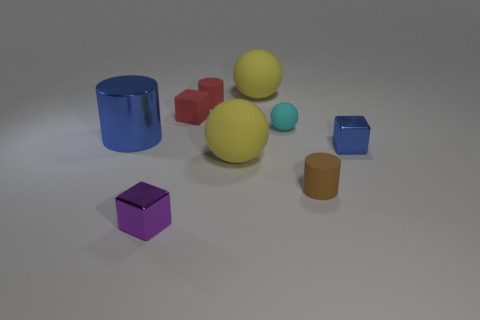What is the largest object in the image? The largest object appears to be the yellow sphere in the middle of the composition. Does the size of the objects convey any particular message? In an artistic sense, the varied sizes could represent the concept of perspective or signify importance, with the larger objects demanding more visual attention. 